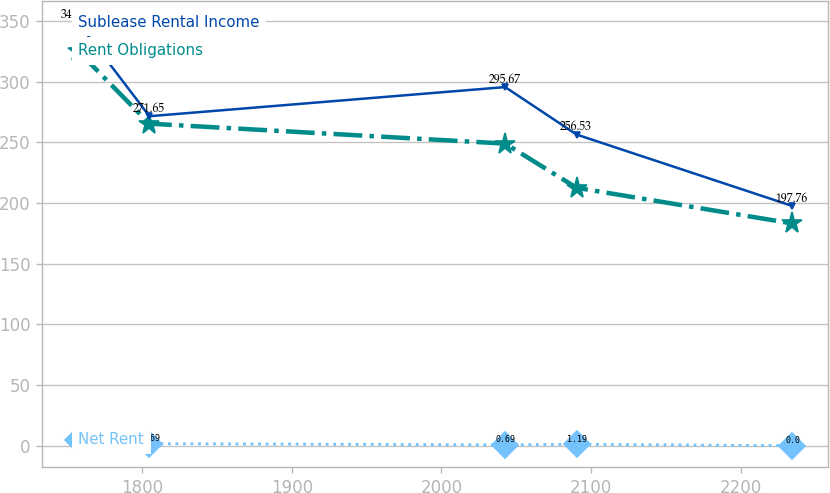Convert chart. <chart><loc_0><loc_0><loc_500><loc_500><line_chart><ecel><fcel>Rent Obligations<fcel>Net Rent<fcel>Sublease Rental Income<nl><fcel>1757.17<fcel>325.37<fcel>5<fcel>348.96<nl><fcel>1804.87<fcel>265.52<fcel>1.69<fcel>271.65<nl><fcel>2042.56<fcel>249.07<fcel>0.69<fcel>295.67<nl><fcel>2090.26<fcel>212.66<fcel>1.19<fcel>256.53<nl><fcel>2234.14<fcel>183.28<fcel>0<fcel>197.76<nl></chart> 